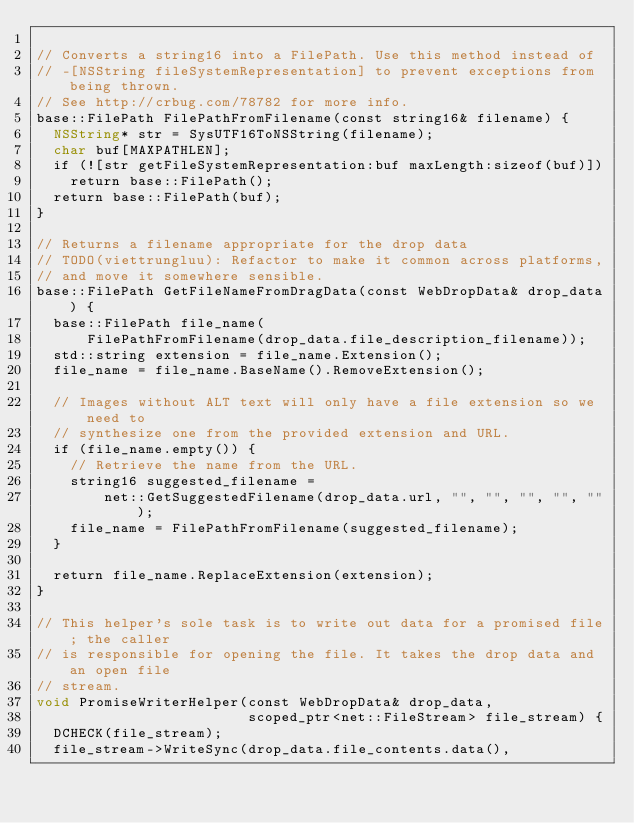<code> <loc_0><loc_0><loc_500><loc_500><_ObjectiveC_>
// Converts a string16 into a FilePath. Use this method instead of
// -[NSString fileSystemRepresentation] to prevent exceptions from being thrown.
// See http://crbug.com/78782 for more info.
base::FilePath FilePathFromFilename(const string16& filename) {
  NSString* str = SysUTF16ToNSString(filename);
  char buf[MAXPATHLEN];
  if (![str getFileSystemRepresentation:buf maxLength:sizeof(buf)])
    return base::FilePath();
  return base::FilePath(buf);
}

// Returns a filename appropriate for the drop data
// TODO(viettrungluu): Refactor to make it common across platforms,
// and move it somewhere sensible.
base::FilePath GetFileNameFromDragData(const WebDropData& drop_data) {
  base::FilePath file_name(
      FilePathFromFilename(drop_data.file_description_filename));
  std::string extension = file_name.Extension();
  file_name = file_name.BaseName().RemoveExtension();

  // Images without ALT text will only have a file extension so we need to
  // synthesize one from the provided extension and URL.
  if (file_name.empty()) {
    // Retrieve the name from the URL.
    string16 suggested_filename =
        net::GetSuggestedFilename(drop_data.url, "", "", "", "", "");
    file_name = FilePathFromFilename(suggested_filename);
  }

  return file_name.ReplaceExtension(extension);
}

// This helper's sole task is to write out data for a promised file; the caller
// is responsible for opening the file. It takes the drop data and an open file
// stream.
void PromiseWriterHelper(const WebDropData& drop_data,
                         scoped_ptr<net::FileStream> file_stream) {
  DCHECK(file_stream);
  file_stream->WriteSync(drop_data.file_contents.data(),</code> 